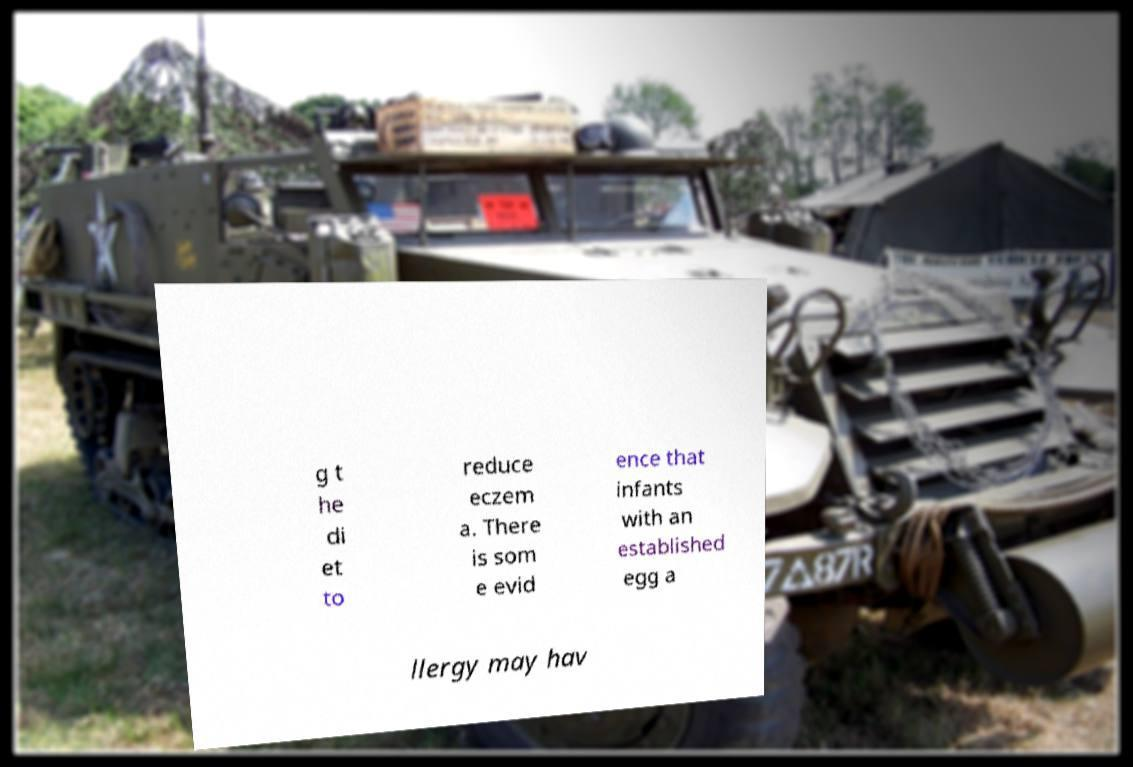I need the written content from this picture converted into text. Can you do that? g t he di et to reduce eczem a. There is som e evid ence that infants with an established egg a llergy may hav 